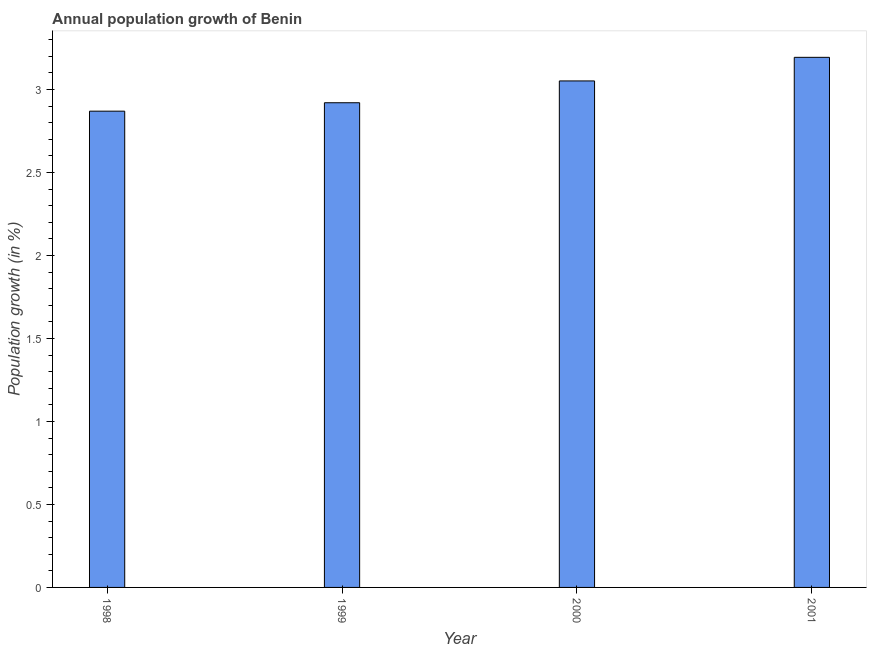Does the graph contain any zero values?
Your answer should be compact. No. Does the graph contain grids?
Offer a terse response. No. What is the title of the graph?
Offer a terse response. Annual population growth of Benin. What is the label or title of the X-axis?
Your answer should be very brief. Year. What is the label or title of the Y-axis?
Offer a terse response. Population growth (in %). What is the population growth in 2001?
Offer a very short reply. 3.19. Across all years, what is the maximum population growth?
Make the answer very short. 3.19. Across all years, what is the minimum population growth?
Provide a succinct answer. 2.87. In which year was the population growth minimum?
Provide a short and direct response. 1998. What is the sum of the population growth?
Keep it short and to the point. 12.04. What is the difference between the population growth in 1999 and 2001?
Ensure brevity in your answer.  -0.27. What is the average population growth per year?
Your answer should be compact. 3.01. What is the median population growth?
Keep it short and to the point. 2.99. In how many years, is the population growth greater than 2.5 %?
Your answer should be compact. 4. What is the ratio of the population growth in 1998 to that in 2001?
Give a very brief answer. 0.9. Is the population growth in 1999 less than that in 2001?
Provide a succinct answer. Yes. Is the difference between the population growth in 1999 and 2001 greater than the difference between any two years?
Provide a short and direct response. No. What is the difference between the highest and the second highest population growth?
Give a very brief answer. 0.14. Is the sum of the population growth in 1998 and 2000 greater than the maximum population growth across all years?
Make the answer very short. Yes. What is the difference between the highest and the lowest population growth?
Provide a short and direct response. 0.32. How many bars are there?
Make the answer very short. 4. What is the Population growth (in %) in 1998?
Provide a short and direct response. 2.87. What is the Population growth (in %) of 1999?
Your answer should be very brief. 2.92. What is the Population growth (in %) in 2000?
Keep it short and to the point. 3.05. What is the Population growth (in %) in 2001?
Keep it short and to the point. 3.19. What is the difference between the Population growth (in %) in 1998 and 1999?
Offer a terse response. -0.05. What is the difference between the Population growth (in %) in 1998 and 2000?
Your answer should be compact. -0.18. What is the difference between the Population growth (in %) in 1998 and 2001?
Your response must be concise. -0.32. What is the difference between the Population growth (in %) in 1999 and 2000?
Your answer should be compact. -0.13. What is the difference between the Population growth (in %) in 1999 and 2001?
Your answer should be very brief. -0.27. What is the difference between the Population growth (in %) in 2000 and 2001?
Provide a succinct answer. -0.14. What is the ratio of the Population growth (in %) in 1998 to that in 1999?
Offer a terse response. 0.98. What is the ratio of the Population growth (in %) in 1998 to that in 2000?
Your response must be concise. 0.94. What is the ratio of the Population growth (in %) in 1998 to that in 2001?
Give a very brief answer. 0.9. What is the ratio of the Population growth (in %) in 1999 to that in 2001?
Provide a succinct answer. 0.91. What is the ratio of the Population growth (in %) in 2000 to that in 2001?
Provide a short and direct response. 0.95. 